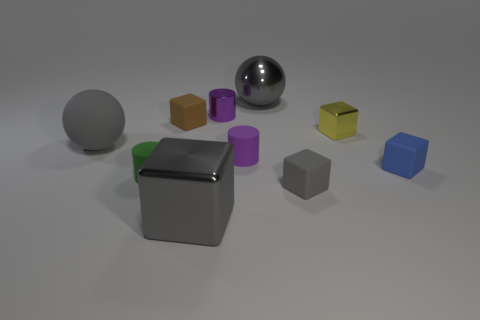Is the material of the large gray object left of the tiny green matte cylinder the same as the big gray object that is behind the tiny yellow shiny cube?
Keep it short and to the point. No. What shape is the tiny blue object that is the same material as the small gray cube?
Your response must be concise. Cube. Are there any other things that are the same color as the big rubber ball?
Provide a succinct answer. Yes. How many small yellow matte objects are there?
Your answer should be very brief. 0. What shape is the tiny object that is both behind the purple rubber object and right of the small gray thing?
Keep it short and to the point. Cube. What is the shape of the gray rubber object to the right of the large gray sphere that is left of the big metallic object that is to the right of the small shiny cylinder?
Keep it short and to the point. Cube. What is the cube that is in front of the tiny yellow metal block and left of the shiny sphere made of?
Keep it short and to the point. Metal. What number of gray shiny balls are the same size as the purple shiny object?
Provide a short and direct response. 0. How many matte objects are either green things or tiny gray blocks?
Make the answer very short. 2. What material is the big block?
Ensure brevity in your answer.  Metal. 